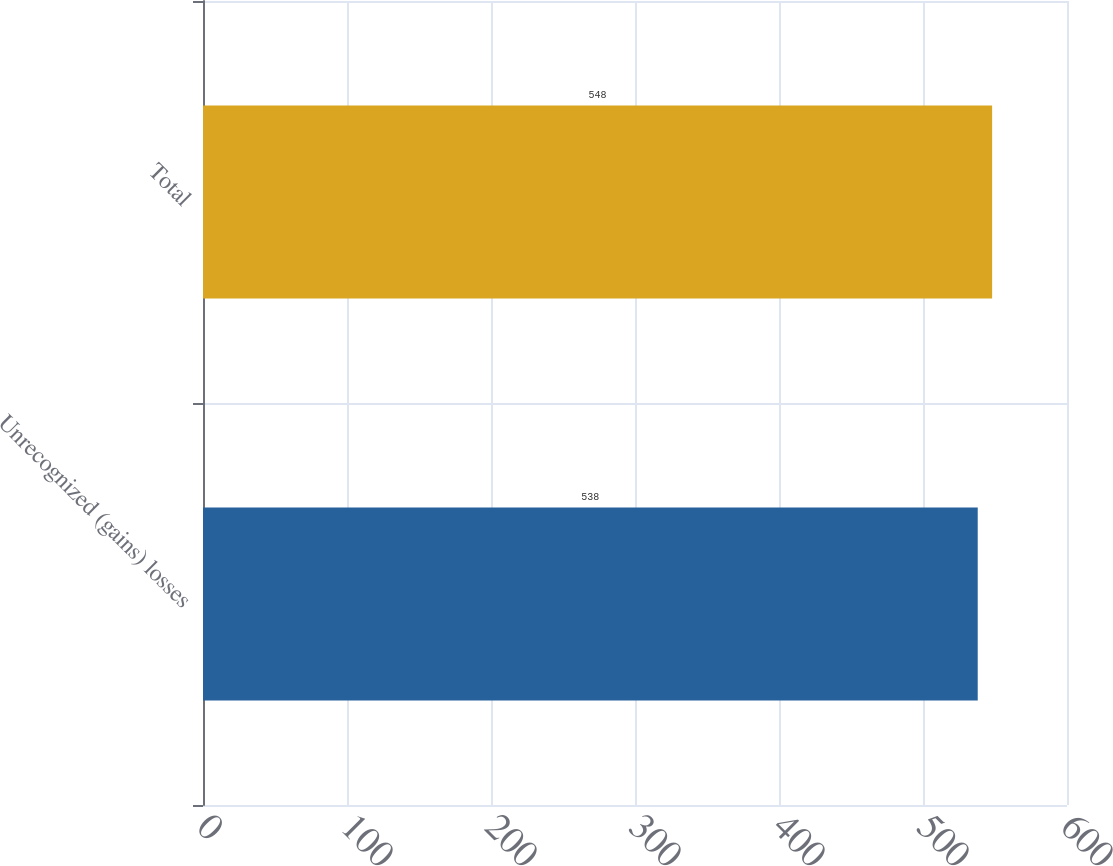Convert chart. <chart><loc_0><loc_0><loc_500><loc_500><bar_chart><fcel>Unrecognized (gains) losses<fcel>Total<nl><fcel>538<fcel>548<nl></chart> 